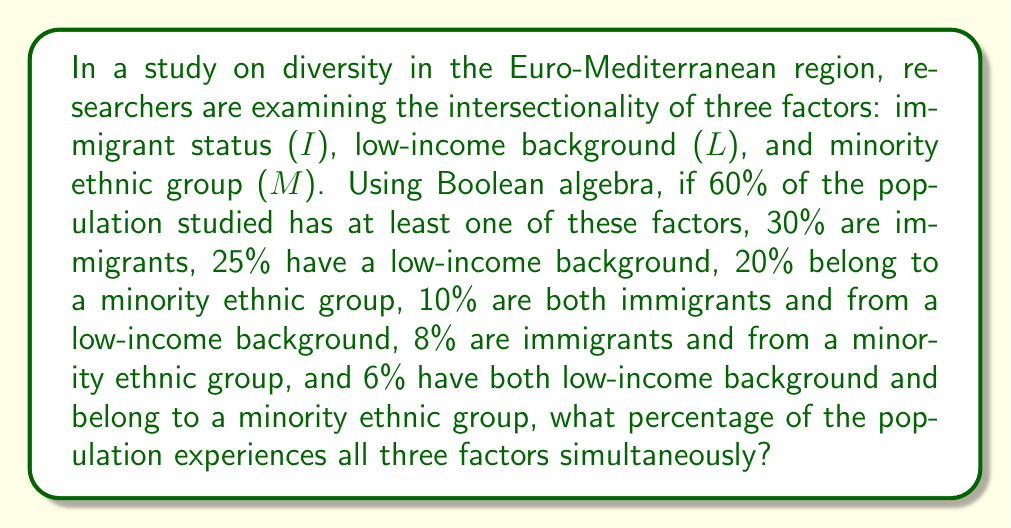Can you solve this math problem? Let's approach this step-by-step using Boolean algebra and the principle of inclusion-exclusion:

1) Let's define our universe as U, and the complement of our set as U'.

2) We're given that 60% of the population has at least one factor, so:
   $P(I \cup L \cup M) = 0.60$

3) Therefore, the complement (those with none of the factors) is:
   $P(U') = 1 - 0.60 = 0.40$

4) Now, let's use the inclusion-exclusion principle:
   $P(I \cup L \cup M) = P(I) + P(L) + P(M) - P(I \cap L) - P(I \cap M) - P(L \cap M) + P(I \cap L \cap M)$

5) We're given most of these values:
   $0.60 = 0.30 + 0.25 + 0.20 - 0.10 - 0.08 - 0.06 + P(I \cap L \cap M)$

6) Let's solve for $P(I \cap L \cap M)$:
   $P(I \cap L \cap M) = 0.60 - (0.30 + 0.25 + 0.20 - 0.10 - 0.08 - 0.06)$
   $P(I \cap L \cap M) = 0.60 - 0.51 = 0.09$

7) Convert to percentage:
   $0.09 * 100 = 9\%$

Therefore, 9% of the population experiences all three factors simultaneously.
Answer: 9% 